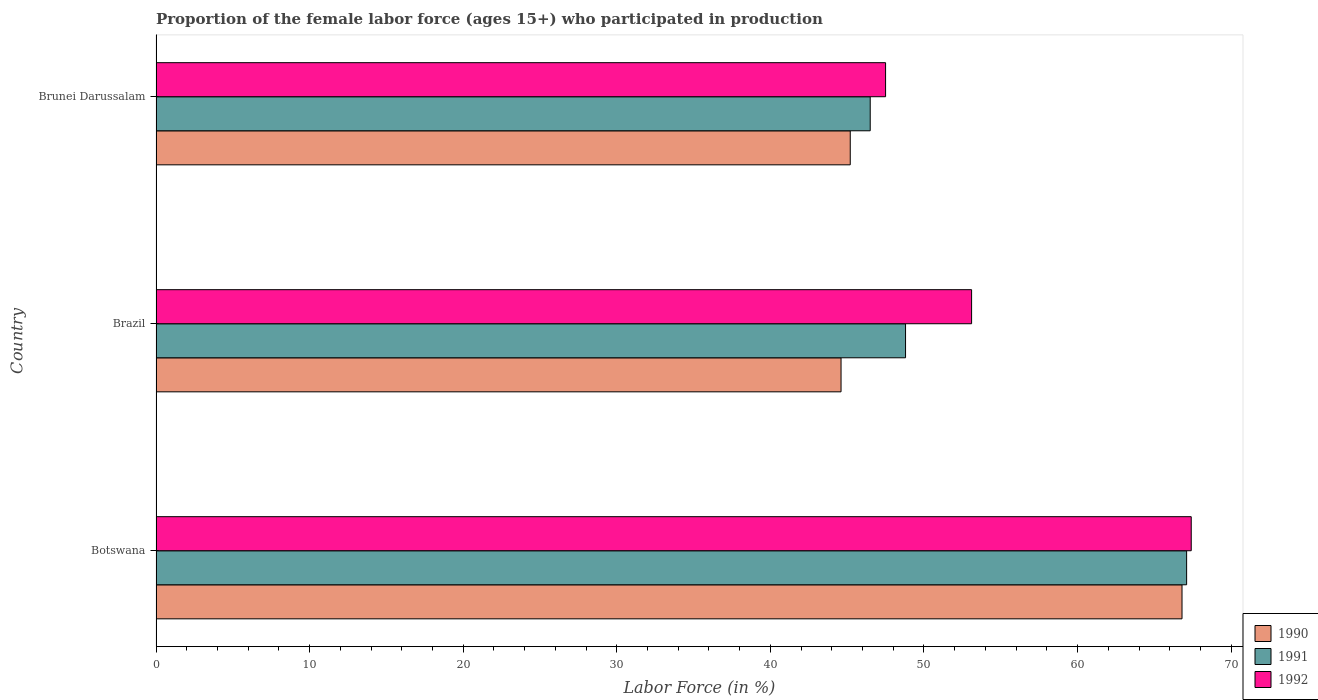How many different coloured bars are there?
Your answer should be compact. 3. How many groups of bars are there?
Provide a succinct answer. 3. Are the number of bars on each tick of the Y-axis equal?
Your answer should be compact. Yes. What is the label of the 3rd group of bars from the top?
Offer a terse response. Botswana. What is the proportion of the female labor force who participated in production in 1990 in Brunei Darussalam?
Offer a terse response. 45.2. Across all countries, what is the maximum proportion of the female labor force who participated in production in 1990?
Your answer should be very brief. 66.8. Across all countries, what is the minimum proportion of the female labor force who participated in production in 1991?
Keep it short and to the point. 46.5. In which country was the proportion of the female labor force who participated in production in 1990 maximum?
Your answer should be very brief. Botswana. What is the total proportion of the female labor force who participated in production in 1991 in the graph?
Provide a short and direct response. 162.4. What is the difference between the proportion of the female labor force who participated in production in 1990 in Botswana and that in Brunei Darussalam?
Your answer should be very brief. 21.6. What is the difference between the proportion of the female labor force who participated in production in 1992 in Brunei Darussalam and the proportion of the female labor force who participated in production in 1991 in Botswana?
Make the answer very short. -19.6. What is the difference between the proportion of the female labor force who participated in production in 1991 and proportion of the female labor force who participated in production in 1992 in Brazil?
Make the answer very short. -4.3. What is the ratio of the proportion of the female labor force who participated in production in 1990 in Botswana to that in Brazil?
Give a very brief answer. 1.5. What is the difference between the highest and the second highest proportion of the female labor force who participated in production in 1990?
Offer a very short reply. 21.6. What is the difference between the highest and the lowest proportion of the female labor force who participated in production in 1992?
Keep it short and to the point. 19.9. What does the 3rd bar from the top in Brazil represents?
Keep it short and to the point. 1990. What does the 2nd bar from the bottom in Botswana represents?
Provide a succinct answer. 1991. Is it the case that in every country, the sum of the proportion of the female labor force who participated in production in 1990 and proportion of the female labor force who participated in production in 1991 is greater than the proportion of the female labor force who participated in production in 1992?
Offer a terse response. Yes. How many bars are there?
Your answer should be compact. 9. Are all the bars in the graph horizontal?
Offer a terse response. Yes. What is the difference between two consecutive major ticks on the X-axis?
Your response must be concise. 10. Are the values on the major ticks of X-axis written in scientific E-notation?
Offer a very short reply. No. Does the graph contain any zero values?
Keep it short and to the point. No. Where does the legend appear in the graph?
Your answer should be compact. Bottom right. How many legend labels are there?
Provide a succinct answer. 3. What is the title of the graph?
Offer a terse response. Proportion of the female labor force (ages 15+) who participated in production. What is the label or title of the X-axis?
Offer a terse response. Labor Force (in %). What is the label or title of the Y-axis?
Give a very brief answer. Country. What is the Labor Force (in %) in 1990 in Botswana?
Ensure brevity in your answer.  66.8. What is the Labor Force (in %) of 1991 in Botswana?
Make the answer very short. 67.1. What is the Labor Force (in %) in 1992 in Botswana?
Your answer should be very brief. 67.4. What is the Labor Force (in %) of 1990 in Brazil?
Ensure brevity in your answer.  44.6. What is the Labor Force (in %) in 1991 in Brazil?
Offer a terse response. 48.8. What is the Labor Force (in %) of 1992 in Brazil?
Your response must be concise. 53.1. What is the Labor Force (in %) of 1990 in Brunei Darussalam?
Make the answer very short. 45.2. What is the Labor Force (in %) in 1991 in Brunei Darussalam?
Your response must be concise. 46.5. What is the Labor Force (in %) in 1992 in Brunei Darussalam?
Provide a succinct answer. 47.5. Across all countries, what is the maximum Labor Force (in %) of 1990?
Keep it short and to the point. 66.8. Across all countries, what is the maximum Labor Force (in %) in 1991?
Make the answer very short. 67.1. Across all countries, what is the maximum Labor Force (in %) in 1992?
Offer a terse response. 67.4. Across all countries, what is the minimum Labor Force (in %) of 1990?
Give a very brief answer. 44.6. Across all countries, what is the minimum Labor Force (in %) in 1991?
Your answer should be compact. 46.5. Across all countries, what is the minimum Labor Force (in %) of 1992?
Provide a succinct answer. 47.5. What is the total Labor Force (in %) in 1990 in the graph?
Provide a short and direct response. 156.6. What is the total Labor Force (in %) in 1991 in the graph?
Offer a terse response. 162.4. What is the total Labor Force (in %) in 1992 in the graph?
Ensure brevity in your answer.  168. What is the difference between the Labor Force (in %) of 1990 in Botswana and that in Brunei Darussalam?
Provide a short and direct response. 21.6. What is the difference between the Labor Force (in %) in 1991 in Botswana and that in Brunei Darussalam?
Offer a very short reply. 20.6. What is the difference between the Labor Force (in %) of 1991 in Brazil and that in Brunei Darussalam?
Offer a terse response. 2.3. What is the difference between the Labor Force (in %) in 1992 in Brazil and that in Brunei Darussalam?
Your answer should be very brief. 5.6. What is the difference between the Labor Force (in %) of 1990 in Botswana and the Labor Force (in %) of 1991 in Brazil?
Keep it short and to the point. 18. What is the difference between the Labor Force (in %) of 1991 in Botswana and the Labor Force (in %) of 1992 in Brazil?
Keep it short and to the point. 14. What is the difference between the Labor Force (in %) in 1990 in Botswana and the Labor Force (in %) in 1991 in Brunei Darussalam?
Your answer should be compact. 20.3. What is the difference between the Labor Force (in %) in 1990 in Botswana and the Labor Force (in %) in 1992 in Brunei Darussalam?
Your answer should be compact. 19.3. What is the difference between the Labor Force (in %) in 1991 in Botswana and the Labor Force (in %) in 1992 in Brunei Darussalam?
Offer a very short reply. 19.6. What is the difference between the Labor Force (in %) of 1990 in Brazil and the Labor Force (in %) of 1991 in Brunei Darussalam?
Ensure brevity in your answer.  -1.9. What is the average Labor Force (in %) in 1990 per country?
Your response must be concise. 52.2. What is the average Labor Force (in %) of 1991 per country?
Ensure brevity in your answer.  54.13. What is the difference between the Labor Force (in %) in 1990 and Labor Force (in %) in 1992 in Brazil?
Offer a terse response. -8.5. What is the difference between the Labor Force (in %) in 1990 and Labor Force (in %) in 1991 in Brunei Darussalam?
Ensure brevity in your answer.  -1.3. What is the difference between the Labor Force (in %) in 1990 and Labor Force (in %) in 1992 in Brunei Darussalam?
Give a very brief answer. -2.3. What is the ratio of the Labor Force (in %) of 1990 in Botswana to that in Brazil?
Offer a terse response. 1.5. What is the ratio of the Labor Force (in %) of 1991 in Botswana to that in Brazil?
Your answer should be compact. 1.38. What is the ratio of the Labor Force (in %) of 1992 in Botswana to that in Brazil?
Offer a terse response. 1.27. What is the ratio of the Labor Force (in %) of 1990 in Botswana to that in Brunei Darussalam?
Make the answer very short. 1.48. What is the ratio of the Labor Force (in %) in 1991 in Botswana to that in Brunei Darussalam?
Your answer should be compact. 1.44. What is the ratio of the Labor Force (in %) in 1992 in Botswana to that in Brunei Darussalam?
Offer a terse response. 1.42. What is the ratio of the Labor Force (in %) of 1990 in Brazil to that in Brunei Darussalam?
Provide a short and direct response. 0.99. What is the ratio of the Labor Force (in %) in 1991 in Brazil to that in Brunei Darussalam?
Offer a terse response. 1.05. What is the ratio of the Labor Force (in %) of 1992 in Brazil to that in Brunei Darussalam?
Offer a terse response. 1.12. What is the difference between the highest and the second highest Labor Force (in %) in 1990?
Your response must be concise. 21.6. What is the difference between the highest and the second highest Labor Force (in %) of 1992?
Ensure brevity in your answer.  14.3. What is the difference between the highest and the lowest Labor Force (in %) in 1991?
Provide a short and direct response. 20.6. 